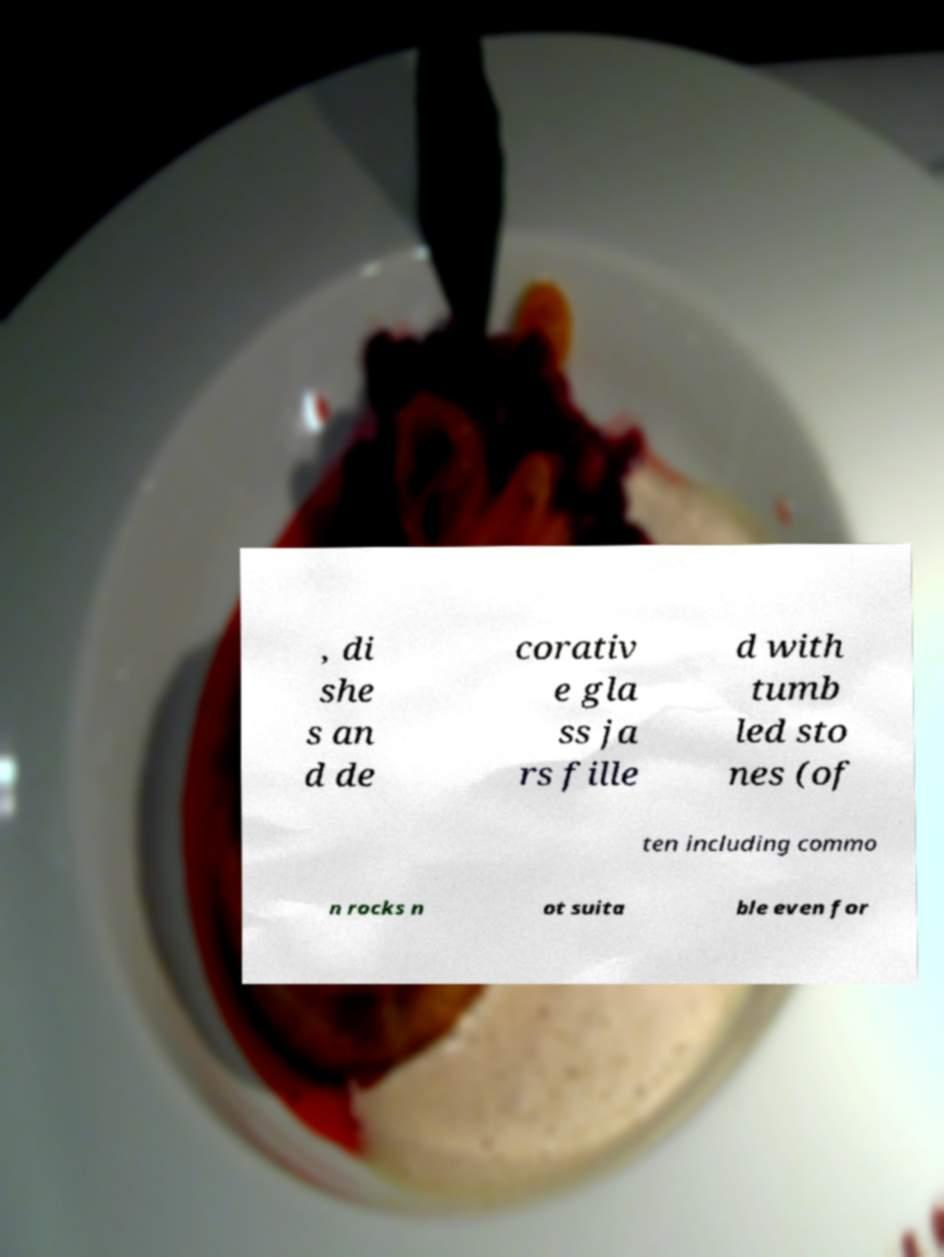Can you accurately transcribe the text from the provided image for me? , di she s an d de corativ e gla ss ja rs fille d with tumb led sto nes (of ten including commo n rocks n ot suita ble even for 